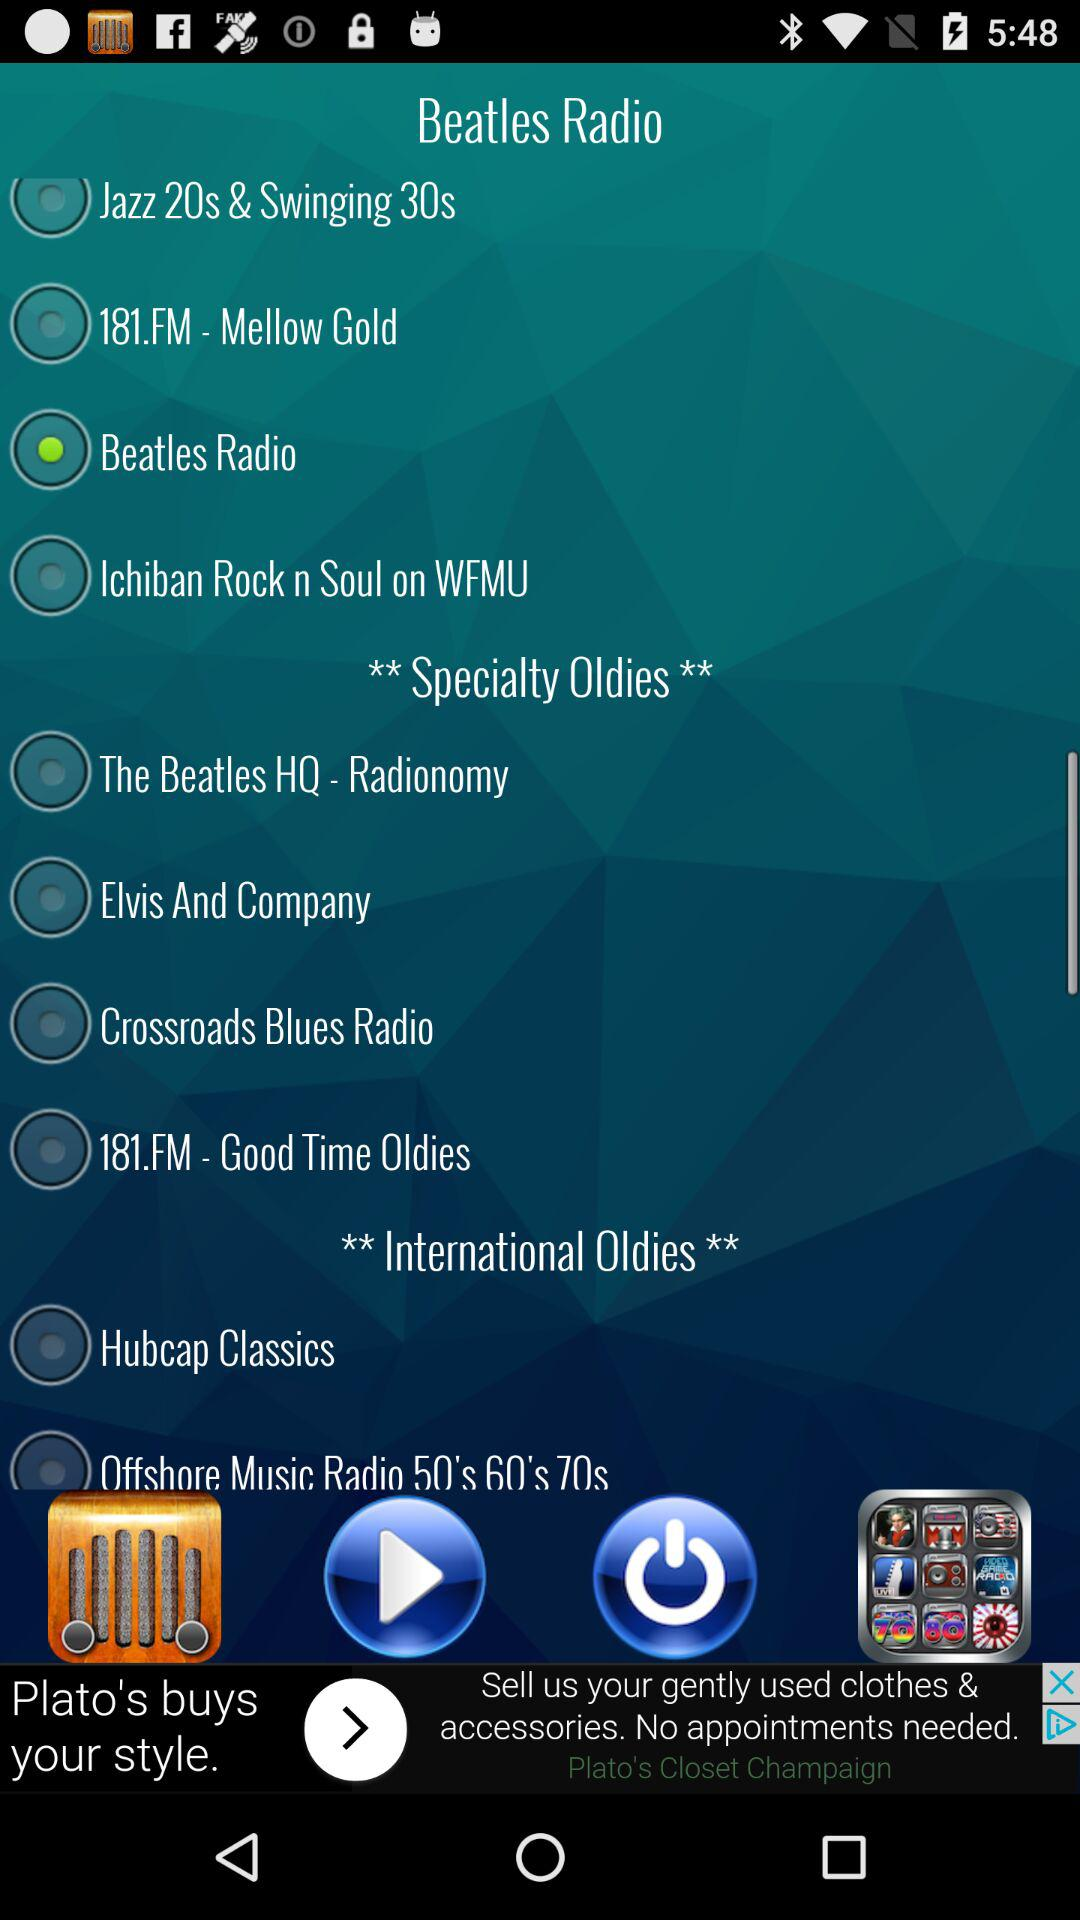Is "Hubcap Classics" selected or not? It is not selected. 